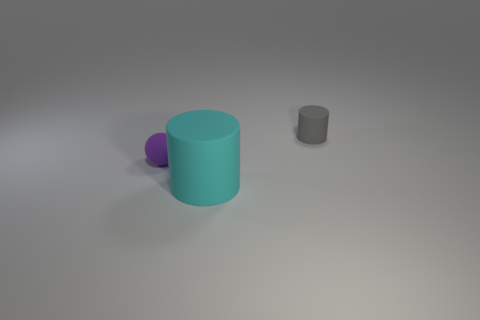Add 3 small gray objects. How many objects exist? 6 Subtract all cylinders. How many objects are left? 1 Add 2 cylinders. How many cylinders exist? 4 Subtract 0 purple blocks. How many objects are left? 3 Subtract all small gray matte cylinders. Subtract all small gray rubber cylinders. How many objects are left? 1 Add 3 large cyan objects. How many large cyan objects are left? 4 